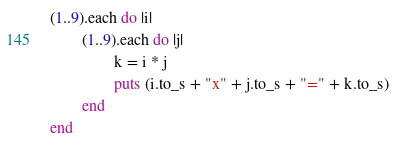Convert code to text. <code><loc_0><loc_0><loc_500><loc_500><_Ruby_>(1..9).each do |i|
        (1..9).each do |j|
                k = i * j
                puts (i.to_s + "x" + j.to_s + "=" + k.to_s)
        end
end

</code> 